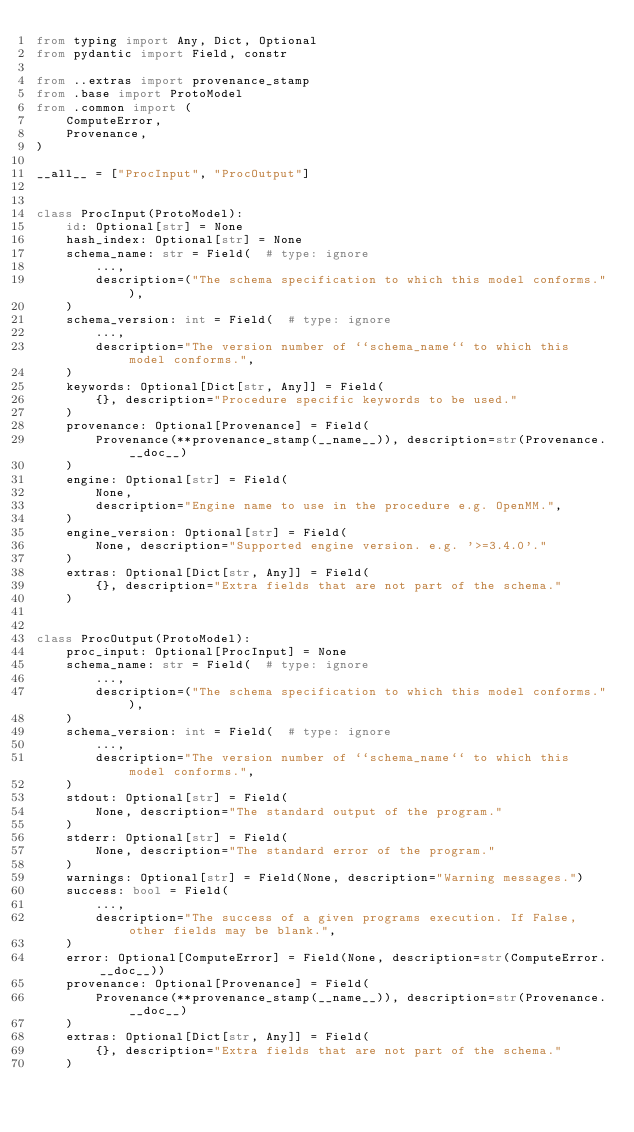<code> <loc_0><loc_0><loc_500><loc_500><_Python_>from typing import Any, Dict, Optional
from pydantic import Field, constr

from ..extras import provenance_stamp
from .base import ProtoModel
from .common import (
    ComputeError,
    Provenance,
)

__all__ = ["ProcInput", "ProcOutput"]


class ProcInput(ProtoModel):
    id: Optional[str] = None
    hash_index: Optional[str] = None
    schema_name: str = Field(  # type: ignore
        ...,
        description=("The schema specification to which this model conforms."),
    )
    schema_version: int = Field(  # type: ignore
        ...,
        description="The version number of ``schema_name`` to which this model conforms.",
    )
    keywords: Optional[Dict[str, Any]] = Field(
        {}, description="Procedure specific keywords to be used."
    )
    provenance: Optional[Provenance] = Field(
        Provenance(**provenance_stamp(__name__)), description=str(Provenance.__doc__)
    )
    engine: Optional[str] = Field(
        None,
        description="Engine name to use in the procedure e.g. OpenMM.",
    )
    engine_version: Optional[str] = Field(
        None, description="Supported engine version. e.g. '>=3.4.0'."
    )
    extras: Optional[Dict[str, Any]] = Field(
        {}, description="Extra fields that are not part of the schema."
    )


class ProcOutput(ProtoModel):
    proc_input: Optional[ProcInput] = None
    schema_name: str = Field(  # type: ignore
        ...,
        description=("The schema specification to which this model conforms."),
    )
    schema_version: int = Field(  # type: ignore
        ...,
        description="The version number of ``schema_name`` to which this model conforms.",
    )
    stdout: Optional[str] = Field(
        None, description="The standard output of the program."
    )
    stderr: Optional[str] = Field(
        None, description="The standard error of the program."
    )
    warnings: Optional[str] = Field(None, description="Warning messages.")
    success: bool = Field(
        ...,
        description="The success of a given programs execution. If False, other fields may be blank.",
    )
    error: Optional[ComputeError] = Field(None, description=str(ComputeError.__doc__))
    provenance: Optional[Provenance] = Field(
        Provenance(**provenance_stamp(__name__)), description=str(Provenance.__doc__)
    )
    extras: Optional[Dict[str, Any]] = Field(
        {}, description="Extra fields that are not part of the schema."
    )
</code> 